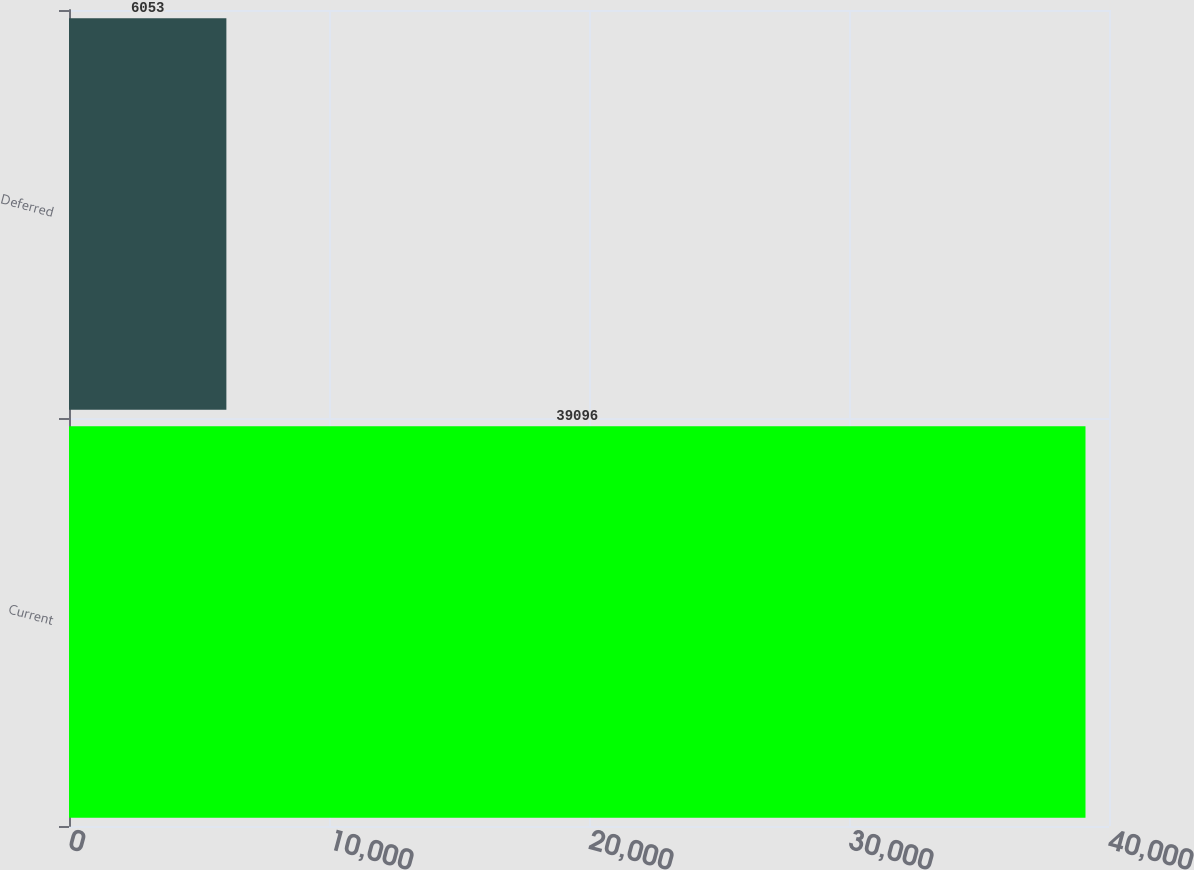Convert chart. <chart><loc_0><loc_0><loc_500><loc_500><bar_chart><fcel>Current<fcel>Deferred<nl><fcel>39096<fcel>6053<nl></chart> 